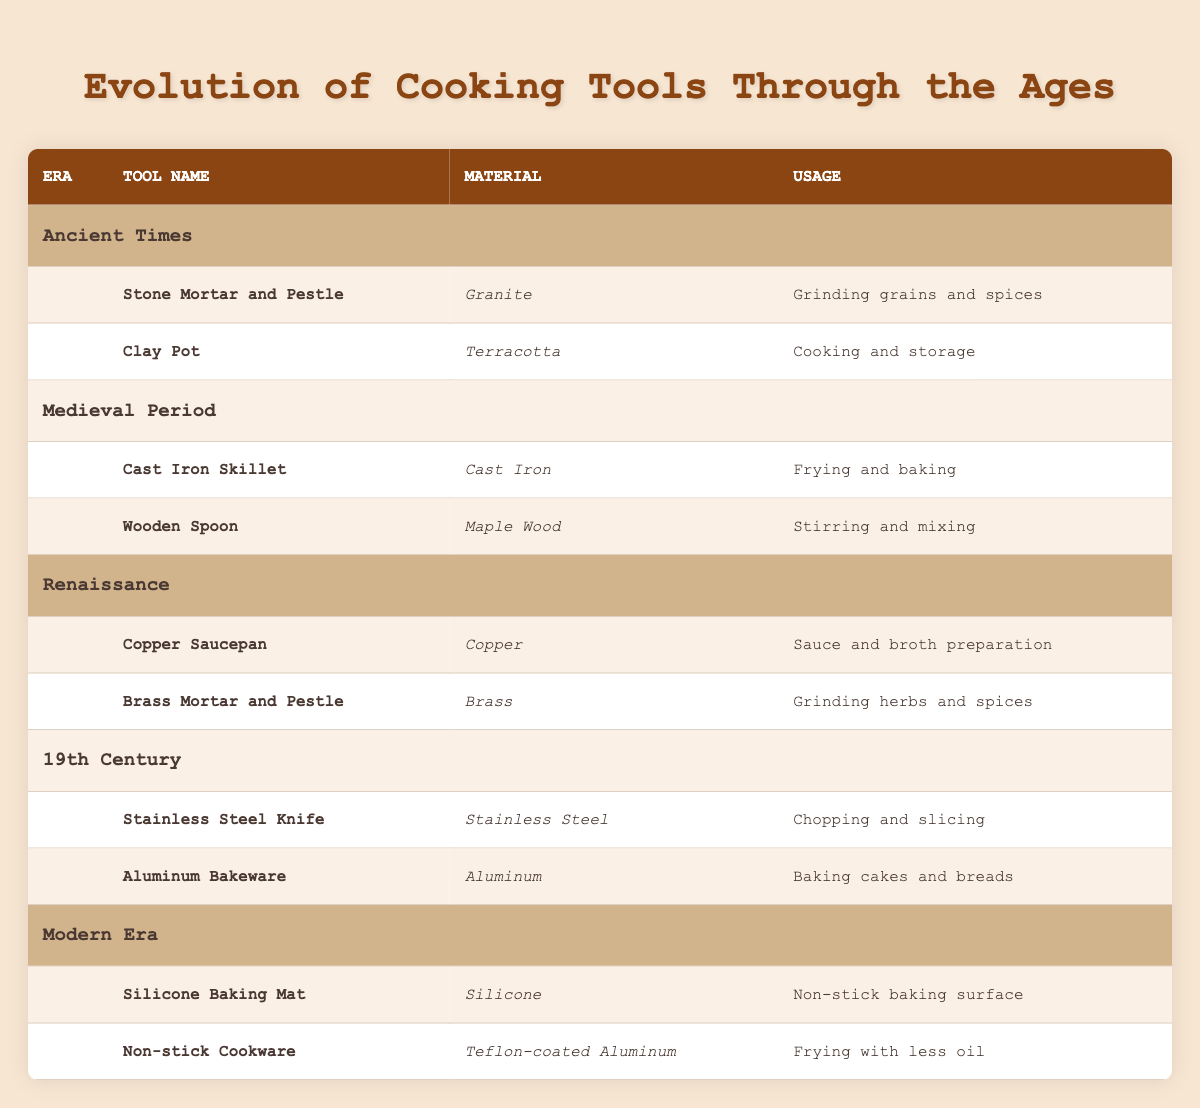What cooking tool is made of granite? The table shows that the "Stone Mortar and Pestle" is made of granite in the Ancient Times era.
Answer: Stone Mortar and Pestle Which material is used for the tool named "Wooden Spoon"? According to the table, the "Wooden Spoon" is made of "Maple Wood" during the Medieval Period.
Answer: Maple Wood Are there any cooking tools made of aluminum? The table lists "Aluminum Bakeware" under the 19th Century, confirming that there is a cooking tool made of aluminum.
Answer: Yes Which era introduced the use of brass for cooking tools? From the table, the "Brass Mortar and Pestle" introduced brass as a material during the Renaissance era.
Answer: Renaissance What is the primary use of the "Copper Saucepan"? The table states that the "Copper Saucepan" is used for "Sauce and broth preparation" in the Renaissance era.
Answer: Sauce and broth preparation How many tools in the table are made of silicon? There is only one tool listed in the table made of silicon, which is the "Silicone Baking Mat" from the Modern Era.
Answer: 1 What material is used for the "Non-stick Cookware"? The table specifies that "Non-stick Cookware" uses "Teflon-coated Aluminum" as its material.
Answer: Teflon-coated Aluminum Which era features a tool made of terracotta? The "Clay Pot," made of terracotta, is featured in the Ancient Times era according to the table.
Answer: Ancient Times What is the difference in materials between tools used in the 19th Century and the Medieval Period? In the 19th Century, tools are made of "Stainless Steel" and "Aluminum," while in the Medieval Period, tools are made of "Cast Iron" and "Maple Wood." Therefore, the difference includes stainless steel and aluminum that are not present in the Medieval Period tools.
Answer: Stainless Steel and Aluminum 